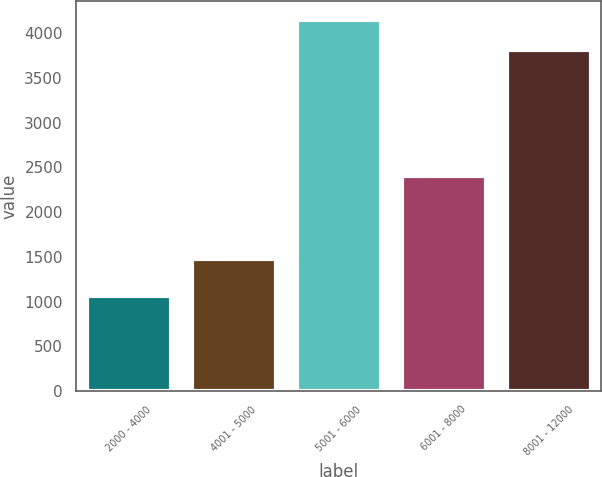Convert chart. <chart><loc_0><loc_0><loc_500><loc_500><bar_chart><fcel>2000 - 4000<fcel>4001 - 5000<fcel>5001 - 6000<fcel>6001 - 8000<fcel>8001 - 12000<nl><fcel>1065<fcel>1477<fcel>4153<fcel>2400<fcel>3808<nl></chart> 